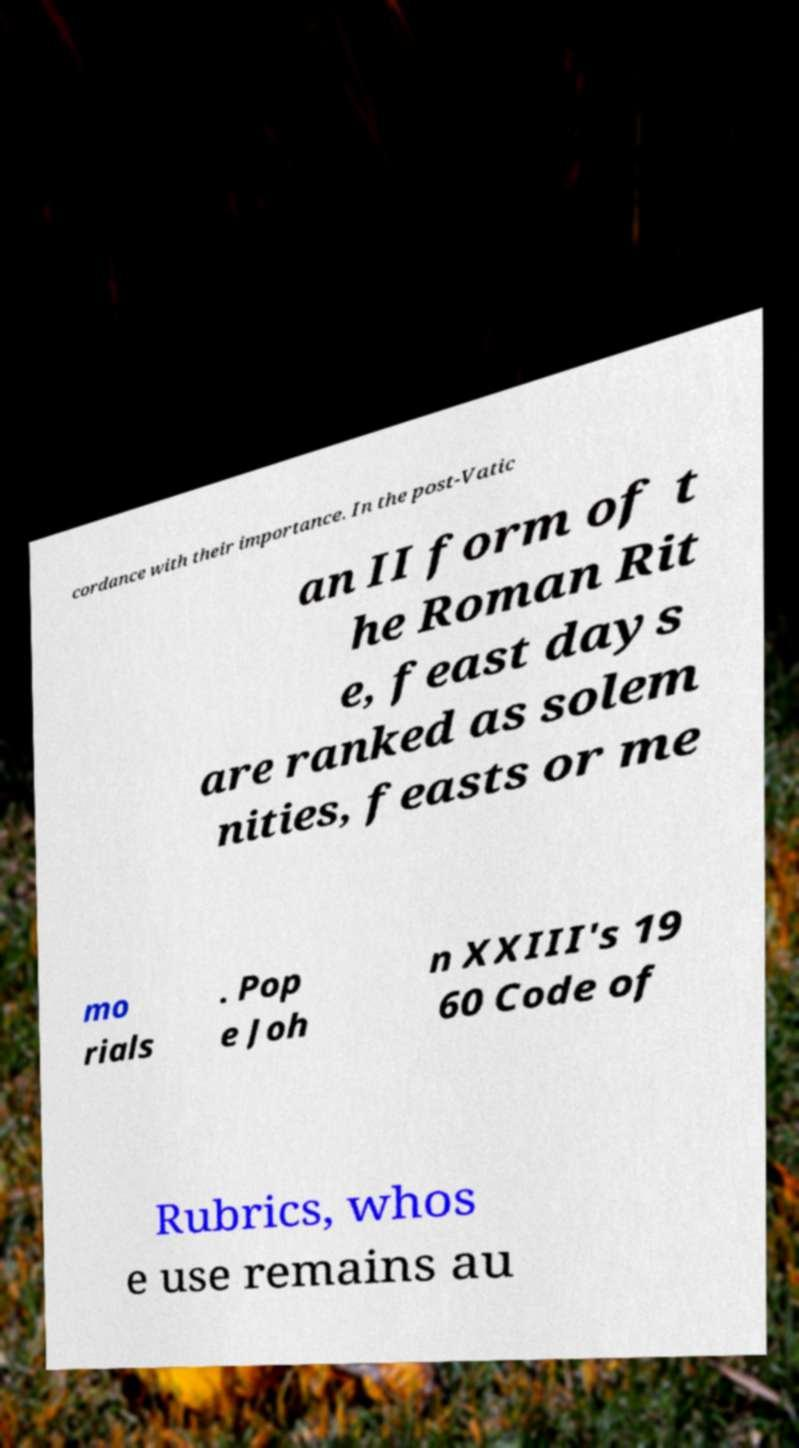Please identify and transcribe the text found in this image. cordance with their importance. In the post-Vatic an II form of t he Roman Rit e, feast days are ranked as solem nities, feasts or me mo rials . Pop e Joh n XXIII's 19 60 Code of Rubrics, whos e use remains au 